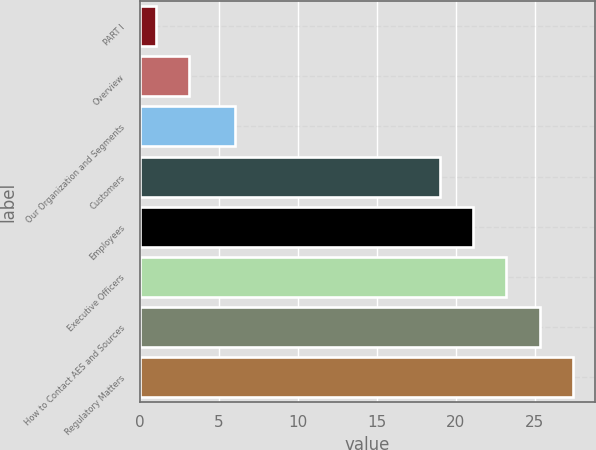Convert chart. <chart><loc_0><loc_0><loc_500><loc_500><bar_chart><fcel>PART I<fcel>Overview<fcel>Our Organization and Segments<fcel>Customers<fcel>Employees<fcel>Executive Officers<fcel>How to Contact AES and Sources<fcel>Regulatory Matters<nl><fcel>1<fcel>3.1<fcel>6<fcel>19<fcel>21.1<fcel>23.2<fcel>25.3<fcel>27.4<nl></chart> 